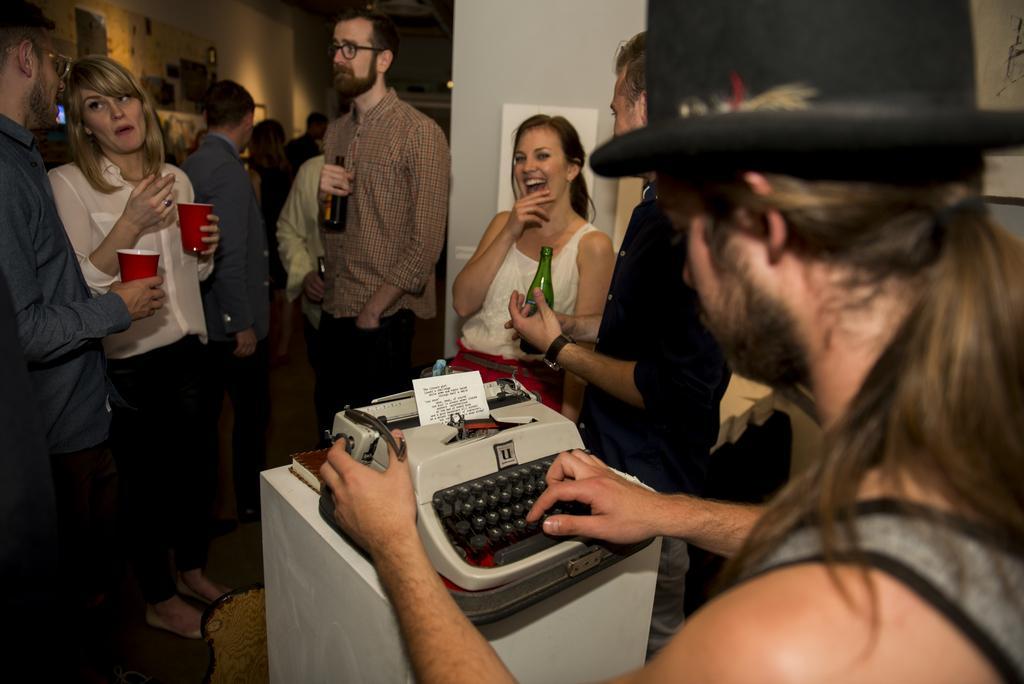In one or two sentences, can you explain what this image depicts? In this image there is a person holding a typing machine, where there is a paper in it, and there is a book , and in the background there are group of people standing and holding the bottles and glasses , frames attached to the wall. 